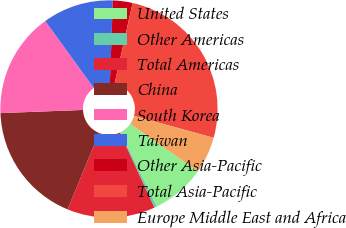Convert chart. <chart><loc_0><loc_0><loc_500><loc_500><pie_chart><fcel>United States<fcel>Other Americas<fcel>Total Americas<fcel>China<fcel>South Korea<fcel>Taiwan<fcel>Other Asia-Pacific<fcel>Total Asia-Pacific<fcel>Europe Middle East and Africa<nl><fcel>8.01%<fcel>0.38%<fcel>13.09%<fcel>18.17%<fcel>15.63%<fcel>10.55%<fcel>2.92%<fcel>25.79%<fcel>5.46%<nl></chart> 